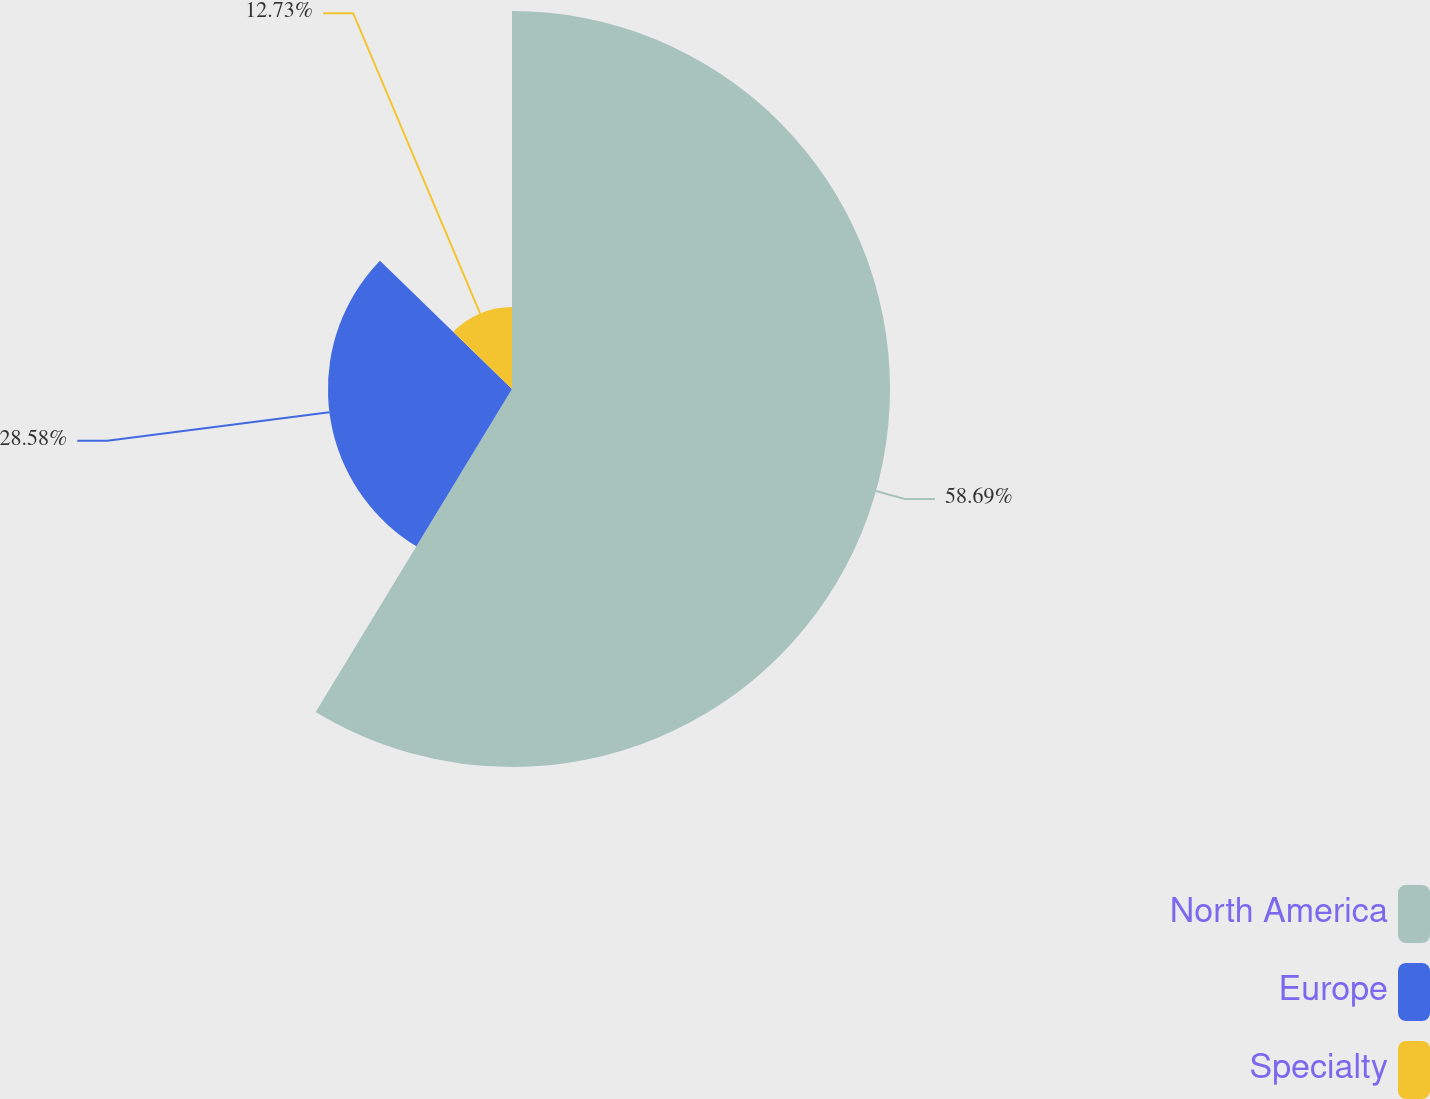Convert chart. <chart><loc_0><loc_0><loc_500><loc_500><pie_chart><fcel>North America<fcel>Europe<fcel>Specialty<nl><fcel>58.69%<fcel>28.58%<fcel>12.73%<nl></chart> 